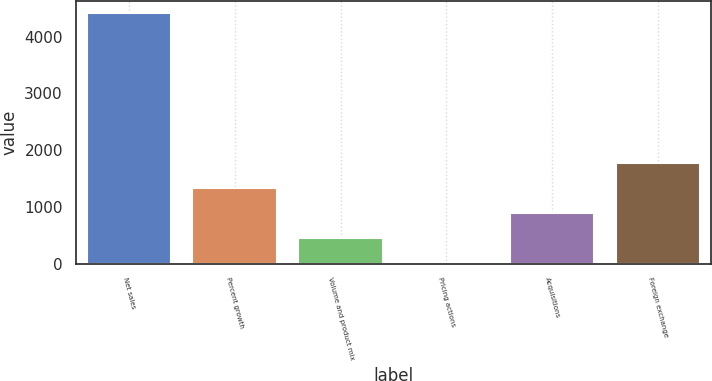<chart> <loc_0><loc_0><loc_500><loc_500><bar_chart><fcel>Net sales<fcel>Percent growth<fcel>Volume and product mix<fcel>Pricing actions<fcel>Acquisitions<fcel>Foreign exchange<nl><fcel>4411.5<fcel>1324.5<fcel>442.5<fcel>1.5<fcel>883.5<fcel>1765.5<nl></chart> 